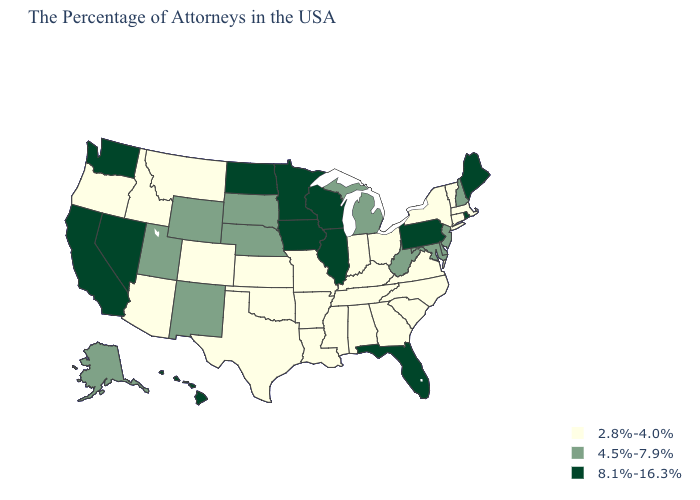What is the value of Illinois?
Answer briefly. 8.1%-16.3%. Name the states that have a value in the range 4.5%-7.9%?
Be succinct. New Hampshire, New Jersey, Delaware, Maryland, West Virginia, Michigan, Nebraska, South Dakota, Wyoming, New Mexico, Utah, Alaska. Is the legend a continuous bar?
Concise answer only. No. What is the lowest value in states that border Michigan?
Answer briefly. 2.8%-4.0%. Which states hav the highest value in the MidWest?
Concise answer only. Wisconsin, Illinois, Minnesota, Iowa, North Dakota. Does Maine have the highest value in the USA?
Keep it brief. Yes. Name the states that have a value in the range 4.5%-7.9%?
Give a very brief answer. New Hampshire, New Jersey, Delaware, Maryland, West Virginia, Michigan, Nebraska, South Dakota, Wyoming, New Mexico, Utah, Alaska. Does Massachusetts have the highest value in the Northeast?
Concise answer only. No. What is the lowest value in the Northeast?
Quick response, please. 2.8%-4.0%. Among the states that border West Virginia , which have the lowest value?
Give a very brief answer. Virginia, Ohio, Kentucky. Among the states that border Louisiana , which have the lowest value?
Answer briefly. Mississippi, Arkansas, Texas. Does Rhode Island have a higher value than Maine?
Write a very short answer. No. Which states have the lowest value in the West?
Keep it brief. Colorado, Montana, Arizona, Idaho, Oregon. What is the value of Idaho?
Short answer required. 2.8%-4.0%. What is the lowest value in the MidWest?
Quick response, please. 2.8%-4.0%. 